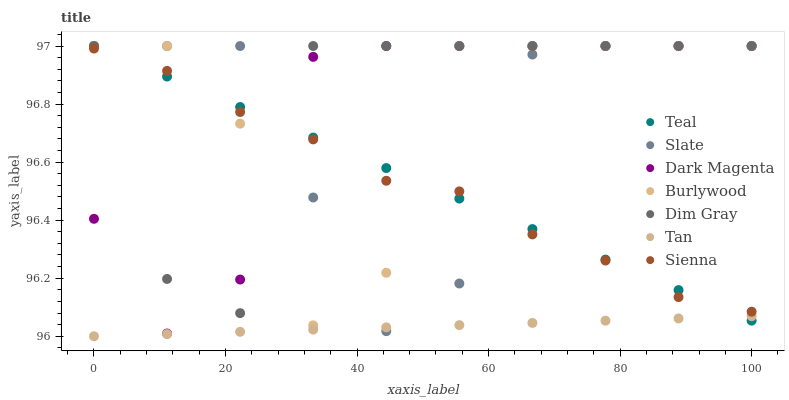Does Tan have the minimum area under the curve?
Answer yes or no. Yes. Does Dim Gray have the maximum area under the curve?
Answer yes or no. Yes. Does Dark Magenta have the minimum area under the curve?
Answer yes or no. No. Does Dark Magenta have the maximum area under the curve?
Answer yes or no. No. Is Tan the smoothest?
Answer yes or no. Yes. Is Burlywood the roughest?
Answer yes or no. Yes. Is Dark Magenta the smoothest?
Answer yes or no. No. Is Dark Magenta the roughest?
Answer yes or no. No. Does Tan have the lowest value?
Answer yes or no. Yes. Does Dark Magenta have the lowest value?
Answer yes or no. No. Does Teal have the highest value?
Answer yes or no. Yes. Does Sienna have the highest value?
Answer yes or no. No. Is Tan less than Burlywood?
Answer yes or no. Yes. Is Sienna greater than Tan?
Answer yes or no. Yes. Does Teal intersect Slate?
Answer yes or no. Yes. Is Teal less than Slate?
Answer yes or no. No. Is Teal greater than Slate?
Answer yes or no. No. Does Tan intersect Burlywood?
Answer yes or no. No. 